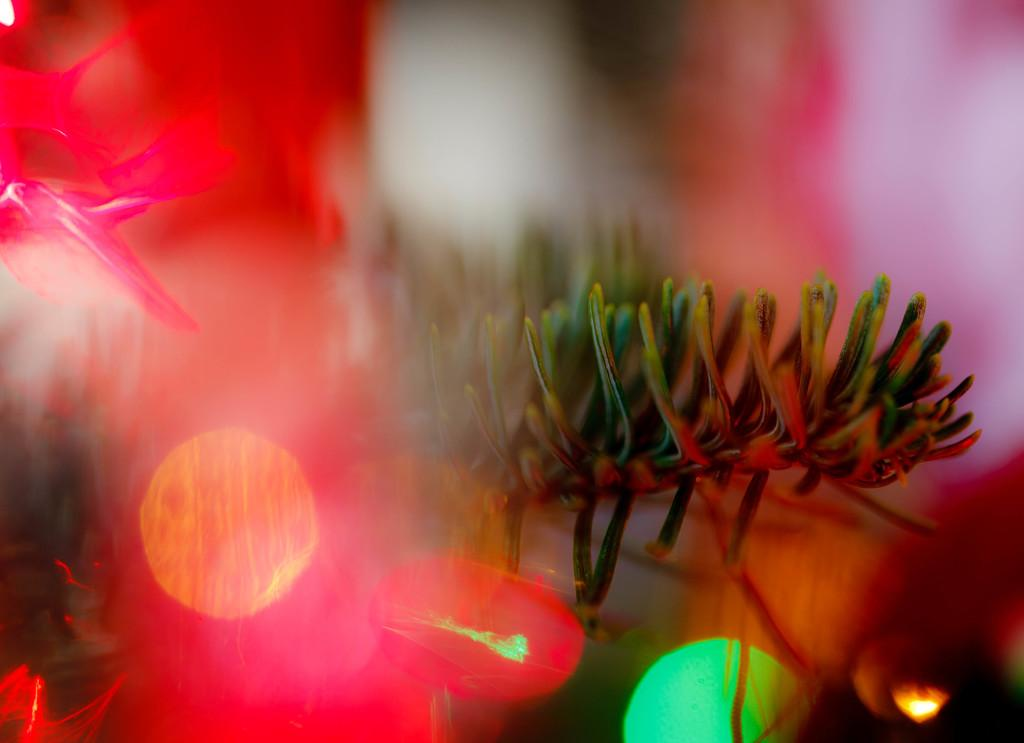What can be seen in the image that emits light? There are lights visible in the image. Can you describe the background of the image? The background of the image appears blurry. How many horses are playing in the background of the image? There are no horses or any indication of play in the image; it only features lights and a blurry background. 